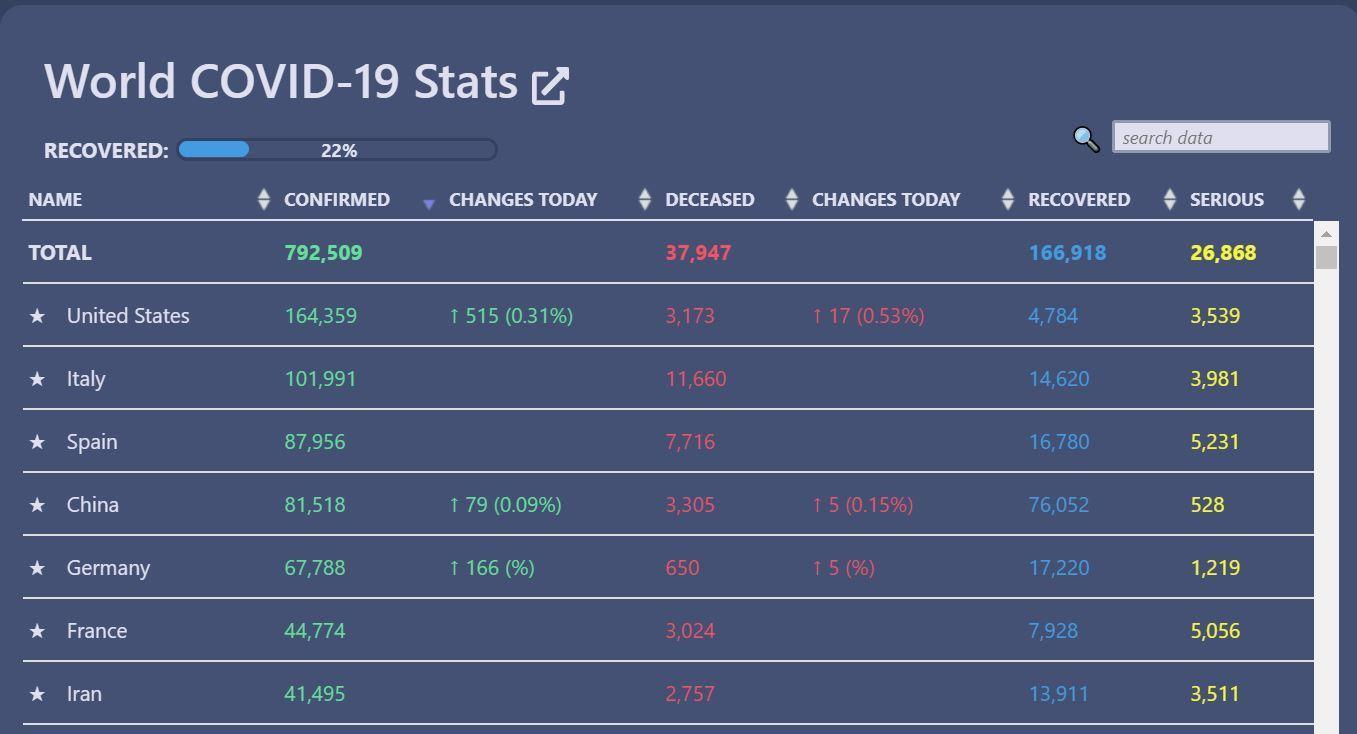What is the total number of confirmed cases in France and Iran, taken together?
Answer the question with a short phrase. 86,269 What is the total number of serious cases in Spain and China, taken together? 5759 What is the total number of death cases in France and Iran, taken together? 5781 What is the total number of recovered cases in Italy and Spain, taken together? 31,400 